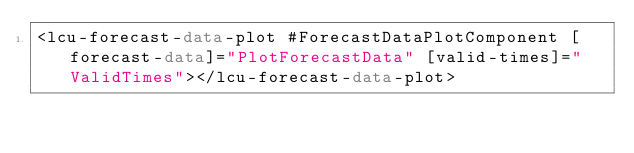<code> <loc_0><loc_0><loc_500><loc_500><_HTML_><lcu-forecast-data-plot #ForecastDataPlotComponent [forecast-data]="PlotForecastData" [valid-times]="ValidTimes"></lcu-forecast-data-plot>
</code> 